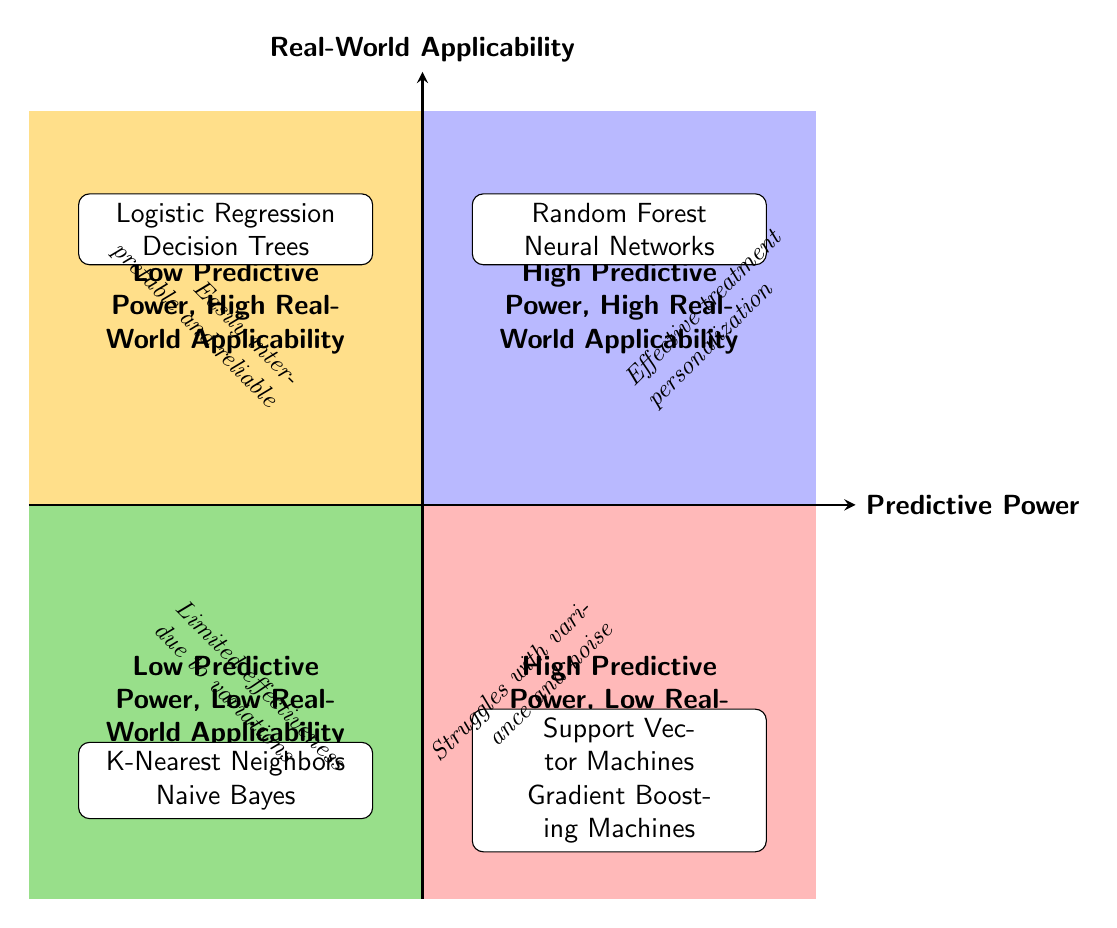What algorithms are placed in the High Predictive Power, High Real-World Applicability quadrant? In the diagram, the High Predictive Power, High Real-World Applicability quadrant contains two algorithms: Random Forest and Neural Networks.
Answer: Random Forest, Neural Networks What is the predictive power of Logistic Regression based on the chart? Logistic Regression is located in the Low Predictive Power, High Real-World Applicability quadrant, which indicates that its predictive power is low.
Answer: Low How many algorithms are in the Low Predictive Power, Low Real-World Applicability quadrant? The Low Predictive Power, Low Real-World Applicability quadrant has two examples listed: K-Nearest Neighbors and Naive Bayes. Thus, there are two algorithms in this quadrant.
Answer: 2 Which algorithm in the High Predictive Power, Low Real-World Applicability quadrant struggles with variance and noise in clinical environments? Support Vector Machines are positioned in the High Predictive Power, Low Real-World Applicability quadrant and are noted to struggle with variance and noise in heterogeneous clinical environments.
Answer: Support Vector Machines What kind of clinical outcome is associated with Neural Networks according to the diagram? The clinical outcome associated with Neural Networks, located in the High Predictive Power, High Real-World Applicability quadrant, is enhanced early diagnosis based on complex biomarkers with consistent success in clinical settings.
Answer: Enhanced early diagnosis What is the relationship between Predictive Power and Real-World Applicability for Decision Trees? Decision Trees are in the Low Predictive Power, High Real-World Applicability quadrant, meaning they have low predictive power but high applicability in real-world clinical decision-making scenarios.
Answer: Low predictive power, high applicability Which quadrant contains algorithms that have excellent performance in simulation studies? The High Predictive Power, Low Real-World Applicability quadrant contains Gradient Boosting Machines, which are noted for their high predictive performance in simulation studies.
Answer: High Predictive Power, Low Real-World Applicability What conclusions can be drawn about the applicability of K-Nearest Neighbors based on the quadrant it resides in? K-Nearest Neighbors, found in the Low Predictive Power, Low Real-World Applicability quadrant, has limited effectiveness due to variations in patient data, implying its low relevance in real-world clinical settings.
Answer: Limited effectiveness 